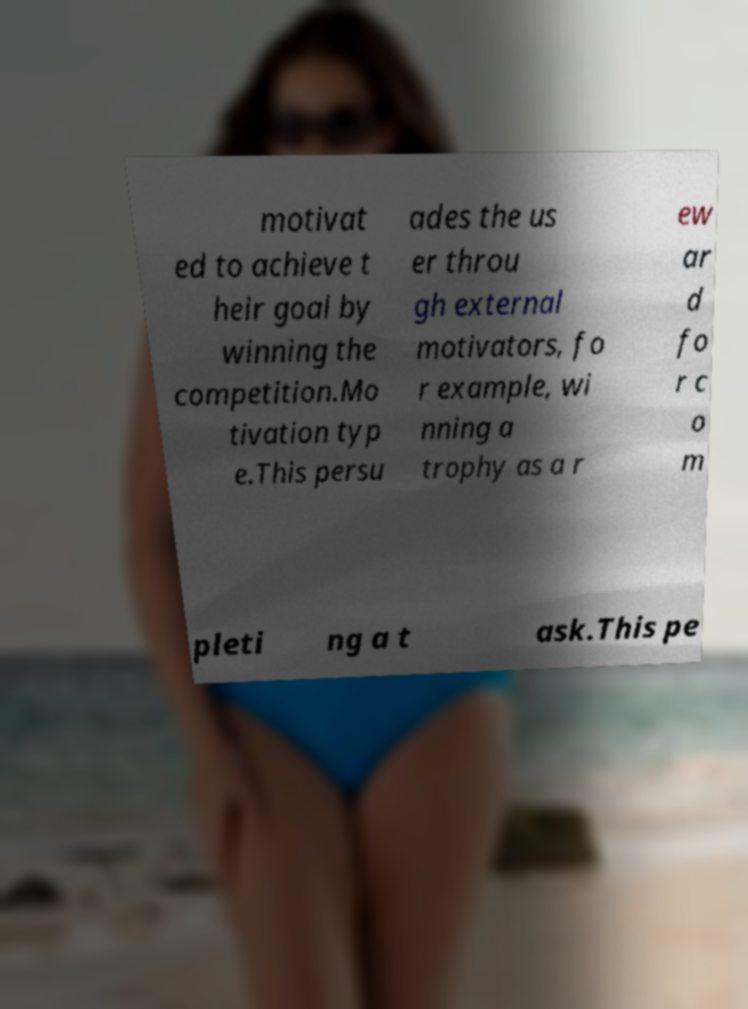There's text embedded in this image that I need extracted. Can you transcribe it verbatim? motivat ed to achieve t heir goal by winning the competition.Mo tivation typ e.This persu ades the us er throu gh external motivators, fo r example, wi nning a trophy as a r ew ar d fo r c o m pleti ng a t ask.This pe 